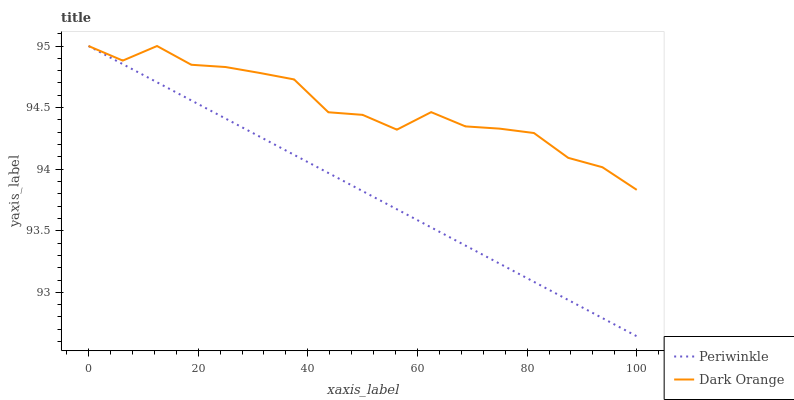Does Periwinkle have the maximum area under the curve?
Answer yes or no. No. Is Periwinkle the roughest?
Answer yes or no. No. 